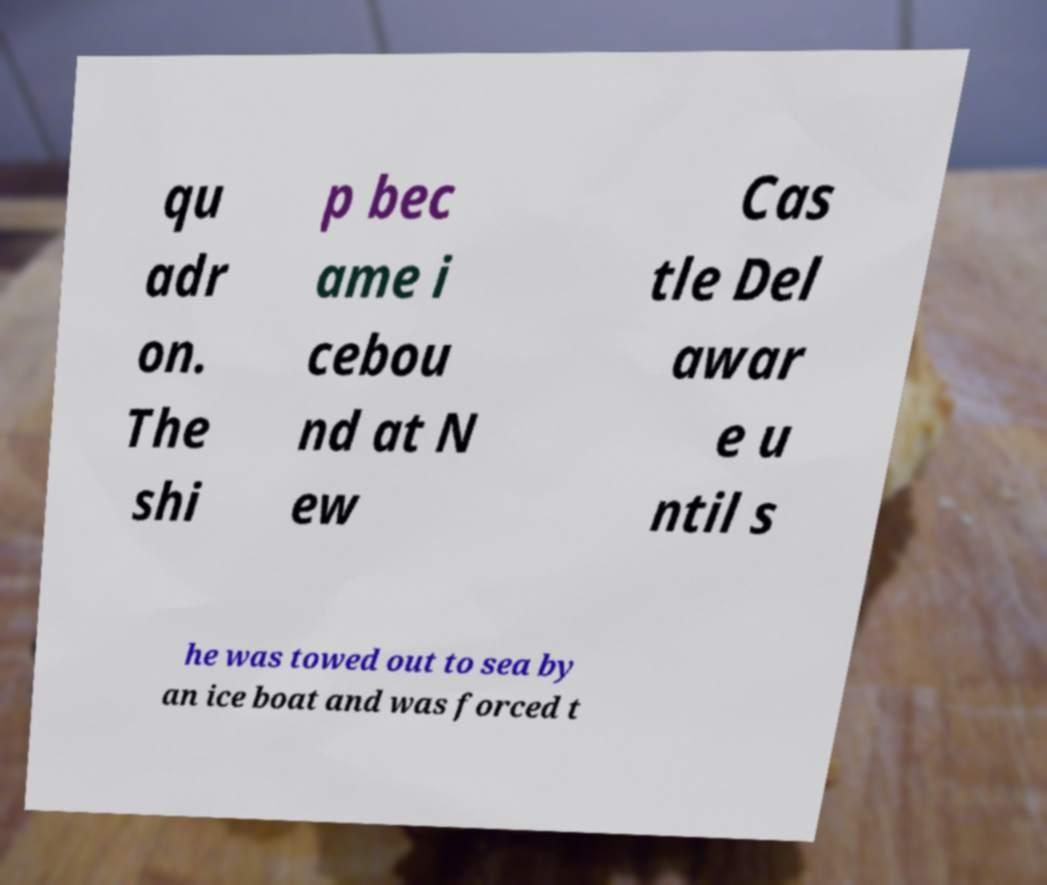Could you assist in decoding the text presented in this image and type it out clearly? qu adr on. The shi p bec ame i cebou nd at N ew Cas tle Del awar e u ntil s he was towed out to sea by an ice boat and was forced t 